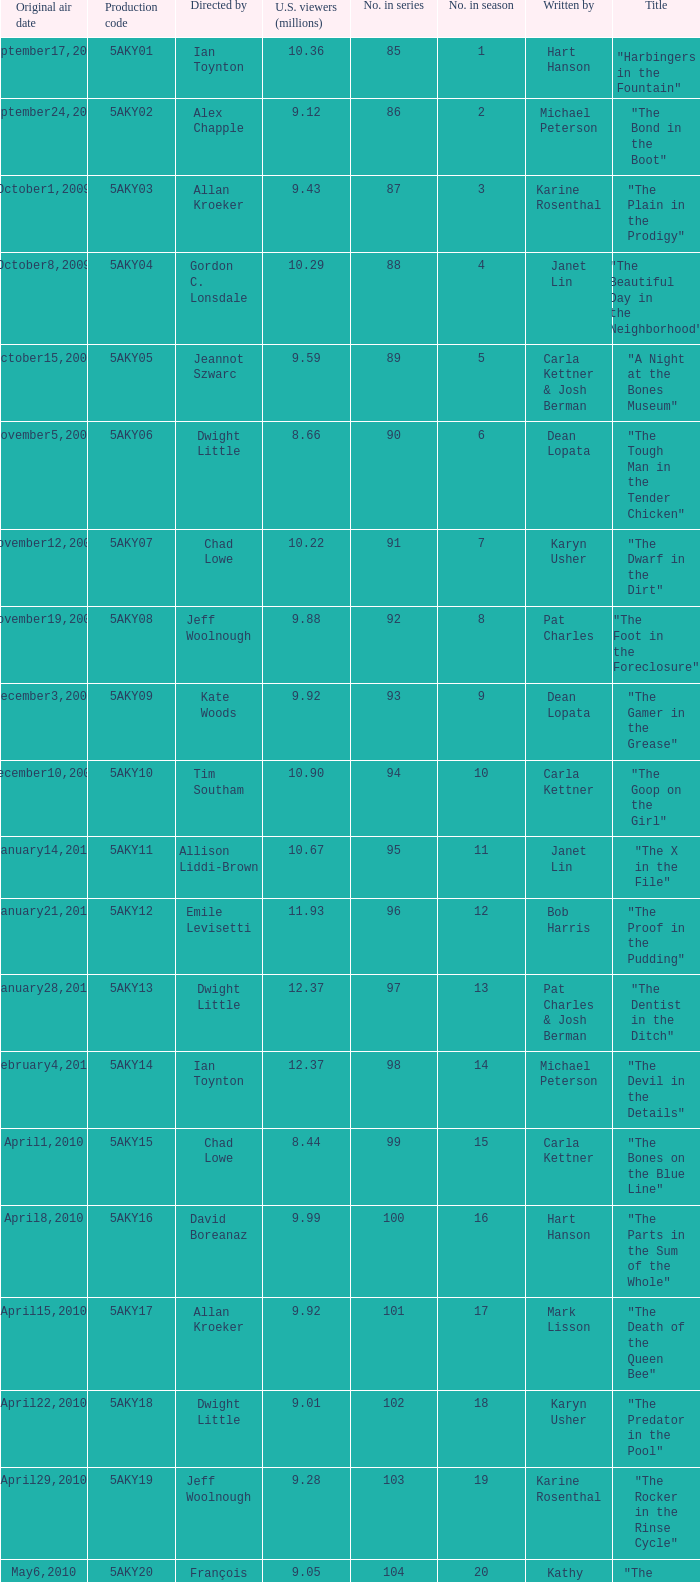How many were the US viewers (in millions) of the episode that was written by Gordon C. Lonsdale? 10.29. 